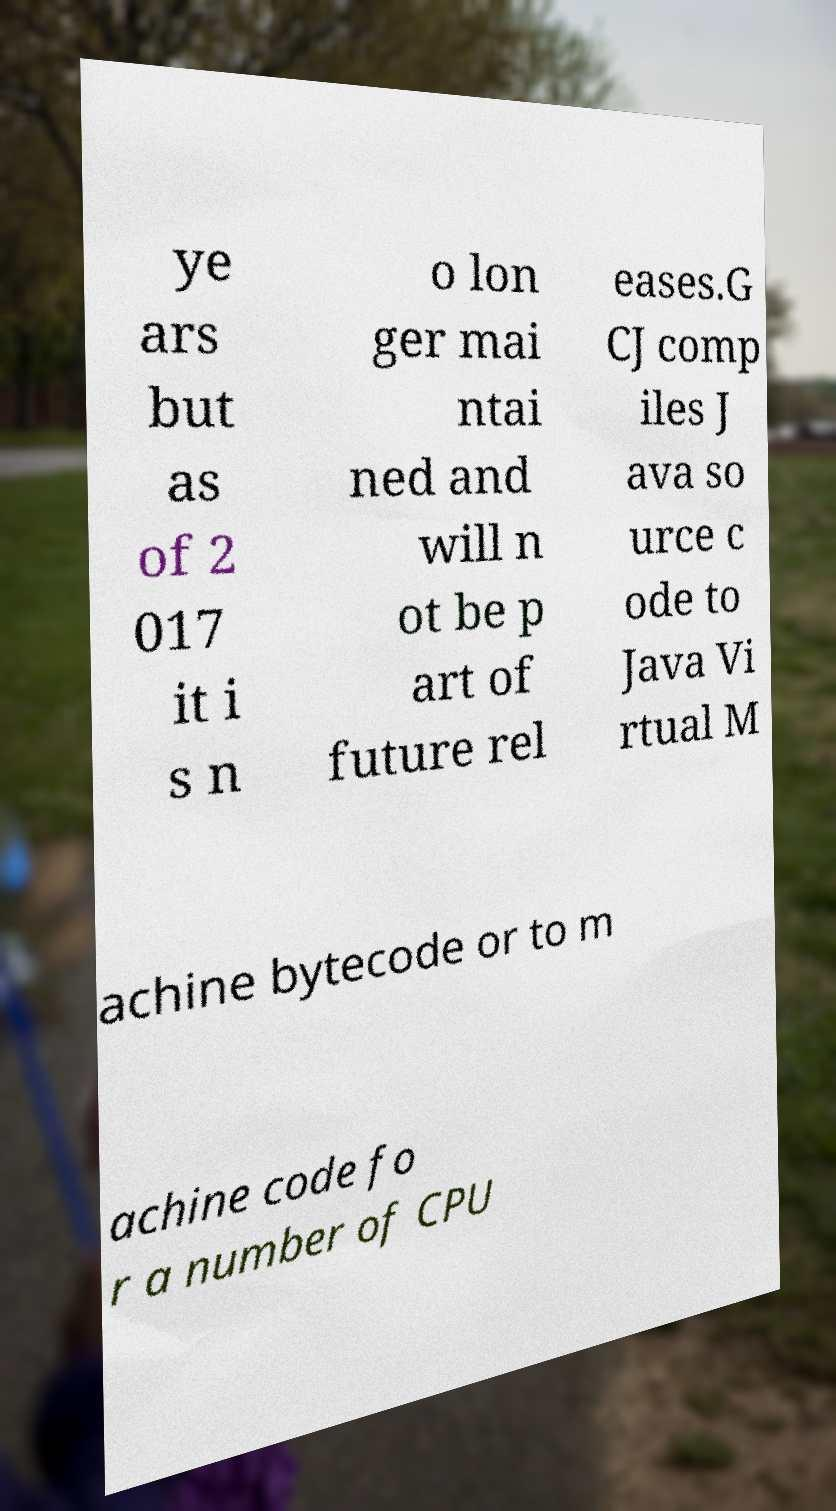Can you read and provide the text displayed in the image?This photo seems to have some interesting text. Can you extract and type it out for me? ye ars but as of 2 017 it i s n o lon ger mai ntai ned and will n ot be p art of future rel eases.G CJ comp iles J ava so urce c ode to Java Vi rtual M achine bytecode or to m achine code fo r a number of CPU 